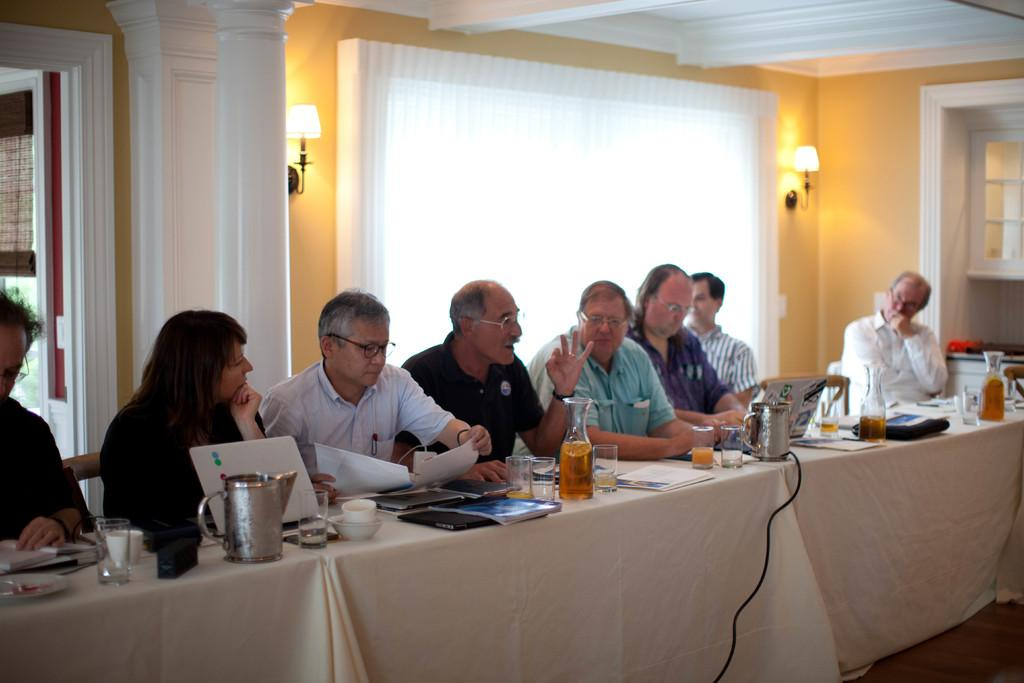What are the people in the image doing? There is a group of people sitting in the image. What objects can be seen on the table in the image? There is a flask, a glass, a laptop, and papers on the table. What is the source of light in the background of the image? There is a lamp in the background. What can be seen outside the window in the background? There is a window in the background, but the facts do not specify what can be seen outside. Is the rain coming through the window in the image? There is no mention of rain in the facts provided, and the image does not show any rain or water coming through the window. 